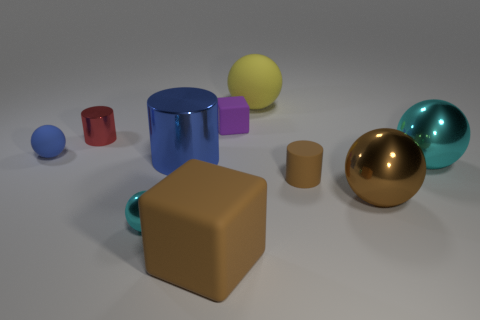There is a thing that is the same color as the big shiny cylinder; what is its size?
Ensure brevity in your answer.  Small. Is the material of the tiny thing to the right of the big yellow matte ball the same as the small purple block?
Your response must be concise. Yes. The red cylinder has what size?
Offer a terse response. Small. What is the shape of the big rubber thing that is the same color as the rubber cylinder?
Offer a very short reply. Cube. What number of spheres are red objects or brown matte things?
Make the answer very short. 0. Are there an equal number of large balls behind the tiny brown rubber cylinder and matte objects behind the blue matte ball?
Your response must be concise. Yes. What size is the other object that is the same shape as the tiny purple object?
Keep it short and to the point. Large. There is a cylinder that is on the right side of the tiny cyan metallic object and on the left side of the purple matte block; how big is it?
Provide a short and direct response. Large. Are there any cyan spheres in front of the big brown metallic sphere?
Offer a terse response. Yes. What number of objects are big things that are to the right of the brown ball or cyan blocks?
Make the answer very short. 1. 